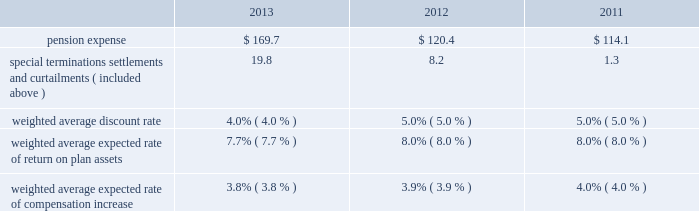Put options we currently have outstanding put option agreements with other shareholders of our air products san fu company , ltd .
And indura s.a .
Subsidiaries .
The put options give the shareholders the right to sell stock in the subsidiaries based on pricing terms in the agreements .
Refer to note 17 , commitments and contingencies , to the consolidated financial statements for additional information .
Due to the uncertainty of whether these options would be exercised and the related timing , we excluded the potential payments from the contractual obligations table .
Pension benefits we sponsor defined benefit pension plans that cover a substantial portion of our worldwide employees .
The principal defined benefit pension plans 2014the u.s .
Salaried pension plan and the u.k .
Pension plan 2014were closed to new participants in 2005 and were replaced with defined contribution plans .
Over the long run , the shift to defined contribution plans is expected to reduce volatility of both plan expense and contributions .
For 2013 , the fair market value of pension plan assets for our defined benefit plans as of the measurement date increased to $ 3800.8 from $ 3239.1 in 2012 .
The projected benefit obligation for these plans as of the measurement date was $ 4394.0 and $ 4486.5 in 2013 and 2012 , respectively .
Refer to note 16 , retirement benefits , to the consolidated financial statements for comprehensive and detailed disclosures on our postretirement benefits .
Pension expense .
2013 vs .
2012 the increase in pension expense , excluding special items , was primarily attributable to the 100 bp decrease in weighted average discount rate , resulting in higher amortization of actuarial losses .
The increase was partially offset by a higher expected return on plan assets and contributions in 2013 .
Special items of $ 19.8 primarily included $ 12.4 for pension settlement losses and $ 6.9 for special termination benefits relating to the 2013 business restructuring and cost reduction plan .
2012 vs .
2011 pension expense in 2012 , excluding special items , was comparable to 2011 expense as a result of no change in the weighted average discount rate from year to year .
2014 outlook pension expense is estimated to be approximately $ 140 to $ 145 , excluding special items , in 2014 , a decrease of $ 5 to $ 10 from 2013 , resulting primarily from an increase in discount rates , partially offset by unfavorable impacts associated with changes in mortality and inflation assumptions .
Pension settlement losses of $ 10 to $ 25 are expected , dependent on the timing of retirements .
In 2014 , pension expense will include approximately $ 118 for amortization of actuarial losses compared to $ 143 in 2013 .
Net actuarial gains of $ 370.4 were recognized in 2013 , resulting primarily from an approximately 65 bp increase in the weighted average discount rate as well as actual asset returns above expected returns .
Actuarial gains/losses are amortized into pension expense over prospective periods to the extent they are not offset by future gains or losses .
Future changes in the discount rate and actual returns on plan assets , different from expected returns , would impact the actuarial gains/losses and resulting amortization in years beyond 2014 .
Pension funding pension funding includes both contributions to funded plans and benefit payments for unfunded plans , which are primarily non-qualified plans .
With respect to funded plans , our funding policy is that contributions , combined with appreciation and earnings , will be sufficient to pay benefits without creating unnecessary surpluses .
In addition , we make contributions to satisfy all legal funding requirements while managing our capacity to benefit from tax deductions attributable to plan contributions .
With the assistance of third party actuaries , we analyze the liabilities and demographics of each plan , which help guide the level of contributions .
During 2013 and 2012 , our cash contributions to funded plans and benefit payments for unfunded plans were $ 300.8 and $ 76.4 , respectively .
Contributions for 2013 include voluntary contributions for u.s .
Plans of $ 220.0. .
Considering the years 2012-2013 , what is the increase observed in the cash contributions to funded plans and benefit payments for unfunded plans? 
Rationale: it is the 2013 value divided by the 2012's , then turned into a percentage and subtracted 100% .
Computations: (((300.8 / 76.4) * 100) - 100)
Answer: 293.71728. Put options we currently have outstanding put option agreements with other shareholders of our air products san fu company , ltd .
And indura s.a .
Subsidiaries .
The put options give the shareholders the right to sell stock in the subsidiaries based on pricing terms in the agreements .
Refer to note 17 , commitments and contingencies , to the consolidated financial statements for additional information .
Due to the uncertainty of whether these options would be exercised and the related timing , we excluded the potential payments from the contractual obligations table .
Pension benefits we sponsor defined benefit pension plans that cover a substantial portion of our worldwide employees .
The principal defined benefit pension plans 2014the u.s .
Salaried pension plan and the u.k .
Pension plan 2014were closed to new participants in 2005 and were replaced with defined contribution plans .
Over the long run , the shift to defined contribution plans is expected to reduce volatility of both plan expense and contributions .
For 2013 , the fair market value of pension plan assets for our defined benefit plans as of the measurement date increased to $ 3800.8 from $ 3239.1 in 2012 .
The projected benefit obligation for these plans as of the measurement date was $ 4394.0 and $ 4486.5 in 2013 and 2012 , respectively .
Refer to note 16 , retirement benefits , to the consolidated financial statements for comprehensive and detailed disclosures on our postretirement benefits .
Pension expense .
2013 vs .
2012 the increase in pension expense , excluding special items , was primarily attributable to the 100 bp decrease in weighted average discount rate , resulting in higher amortization of actuarial losses .
The increase was partially offset by a higher expected return on plan assets and contributions in 2013 .
Special items of $ 19.8 primarily included $ 12.4 for pension settlement losses and $ 6.9 for special termination benefits relating to the 2013 business restructuring and cost reduction plan .
2012 vs .
2011 pension expense in 2012 , excluding special items , was comparable to 2011 expense as a result of no change in the weighted average discount rate from year to year .
2014 outlook pension expense is estimated to be approximately $ 140 to $ 145 , excluding special items , in 2014 , a decrease of $ 5 to $ 10 from 2013 , resulting primarily from an increase in discount rates , partially offset by unfavorable impacts associated with changes in mortality and inflation assumptions .
Pension settlement losses of $ 10 to $ 25 are expected , dependent on the timing of retirements .
In 2014 , pension expense will include approximately $ 118 for amortization of actuarial losses compared to $ 143 in 2013 .
Net actuarial gains of $ 370.4 were recognized in 2013 , resulting primarily from an approximately 65 bp increase in the weighted average discount rate as well as actual asset returns above expected returns .
Actuarial gains/losses are amortized into pension expense over prospective periods to the extent they are not offset by future gains or losses .
Future changes in the discount rate and actual returns on plan assets , different from expected returns , would impact the actuarial gains/losses and resulting amortization in years beyond 2014 .
Pension funding pension funding includes both contributions to funded plans and benefit payments for unfunded plans , which are primarily non-qualified plans .
With respect to funded plans , our funding policy is that contributions , combined with appreciation and earnings , will be sufficient to pay benefits without creating unnecessary surpluses .
In addition , we make contributions to satisfy all legal funding requirements while managing our capacity to benefit from tax deductions attributable to plan contributions .
With the assistance of third party actuaries , we analyze the liabilities and demographics of each plan , which help guide the level of contributions .
During 2013 and 2012 , our cash contributions to funded plans and benefit payments for unfunded plans were $ 300.8 and $ 76.4 , respectively .
Contributions for 2013 include voluntary contributions for u.s .
Plans of $ 220.0. .
Considering the years 2012-2013 , what is the increase observed in the special terminations settlements and curtailments? 
Rationale: it is the 2013 value divided by the 2012's , then turned into a percentage and subtracted 100% .
Computations: (((19.8 / 8.2) * 100) - 100)
Answer: 141.46341. 